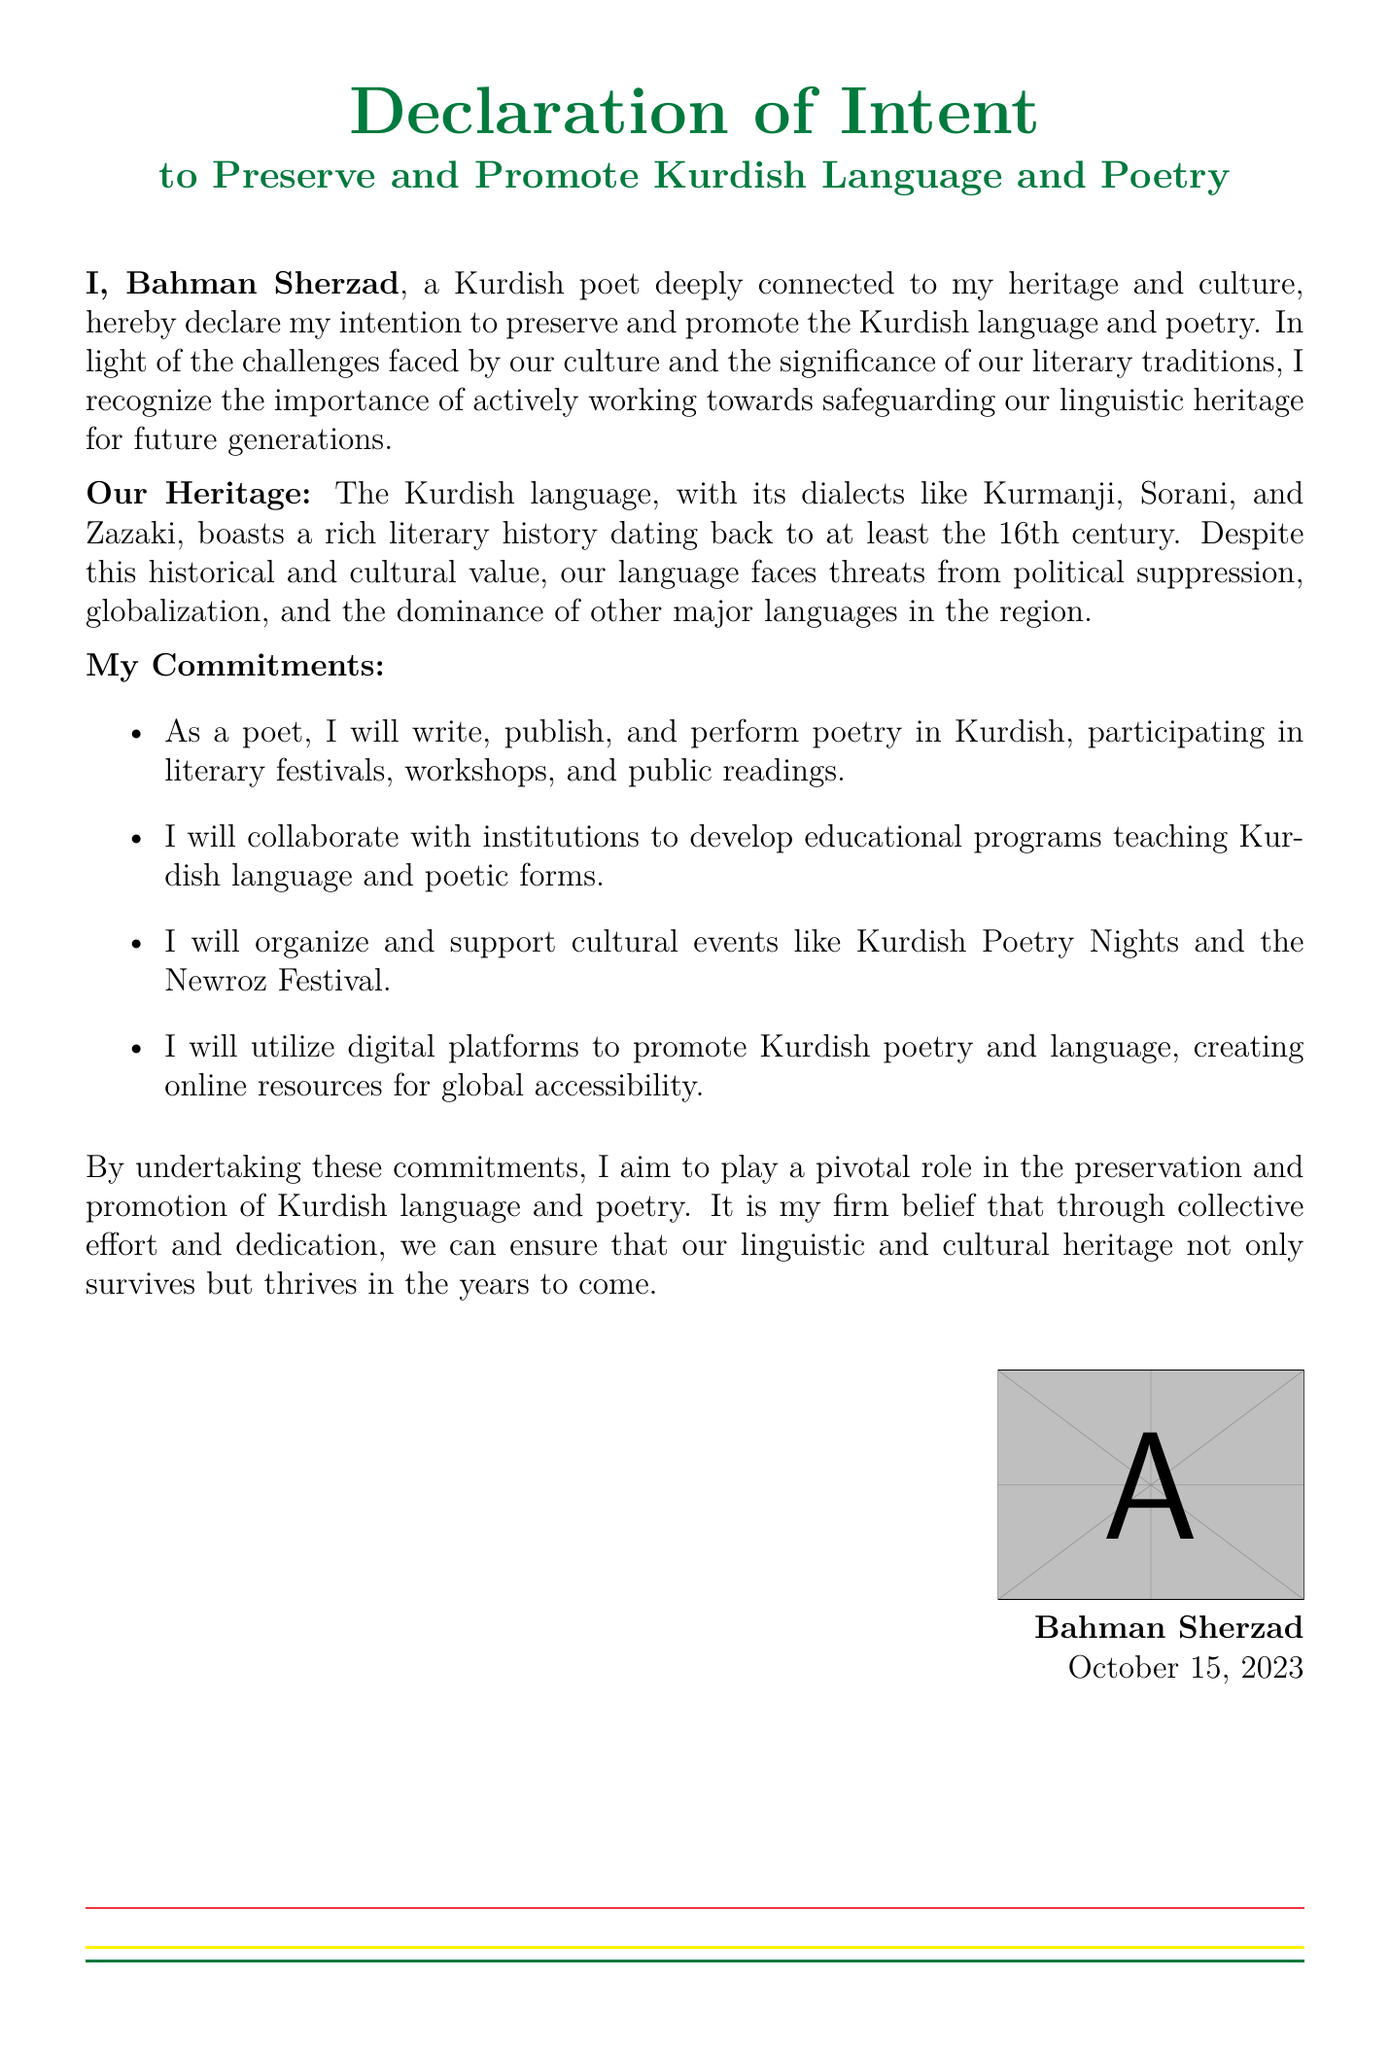What is the name of the person making the declaration? The document states the declarant's name at the beginning.
Answer: Bahman Sherzad What is the date of the declaration? The date can be found at the bottom of the document near the signature.
Answer: October 15, 2023 What are the dialects of the Kurdish language mentioned? The document lists the dialects in the section about heritage.
Answer: Kurmanji, Sorani, Zazaki What type of events will the declarant organize to promote Kurdish poetry? The document mentions specific types of cultural events that will be organized.
Answer: Kurdish Poetry Nights and the Newroz Festival What is one way the declarant plans to utilize digital platforms? The document mentions how digital platforms will be used in relation to Kurdish poetry.
Answer: Creating online resources for global accessibility What is the declarant's profession? The document indicates the role of the individual making the declaration.
Answer: Poet What is the color associated with the document's header? The header is colored, and the specific color is mentioned in the document.
Answer: Kurdish green What is the primary intent of this declaration? The document clearly states the reason for the declaration in the opening statement.
Answer: To preserve and promote Kurdish language and poetry 